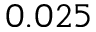Convert formula to latex. <formula><loc_0><loc_0><loc_500><loc_500>0 . 0 2 5</formula> 